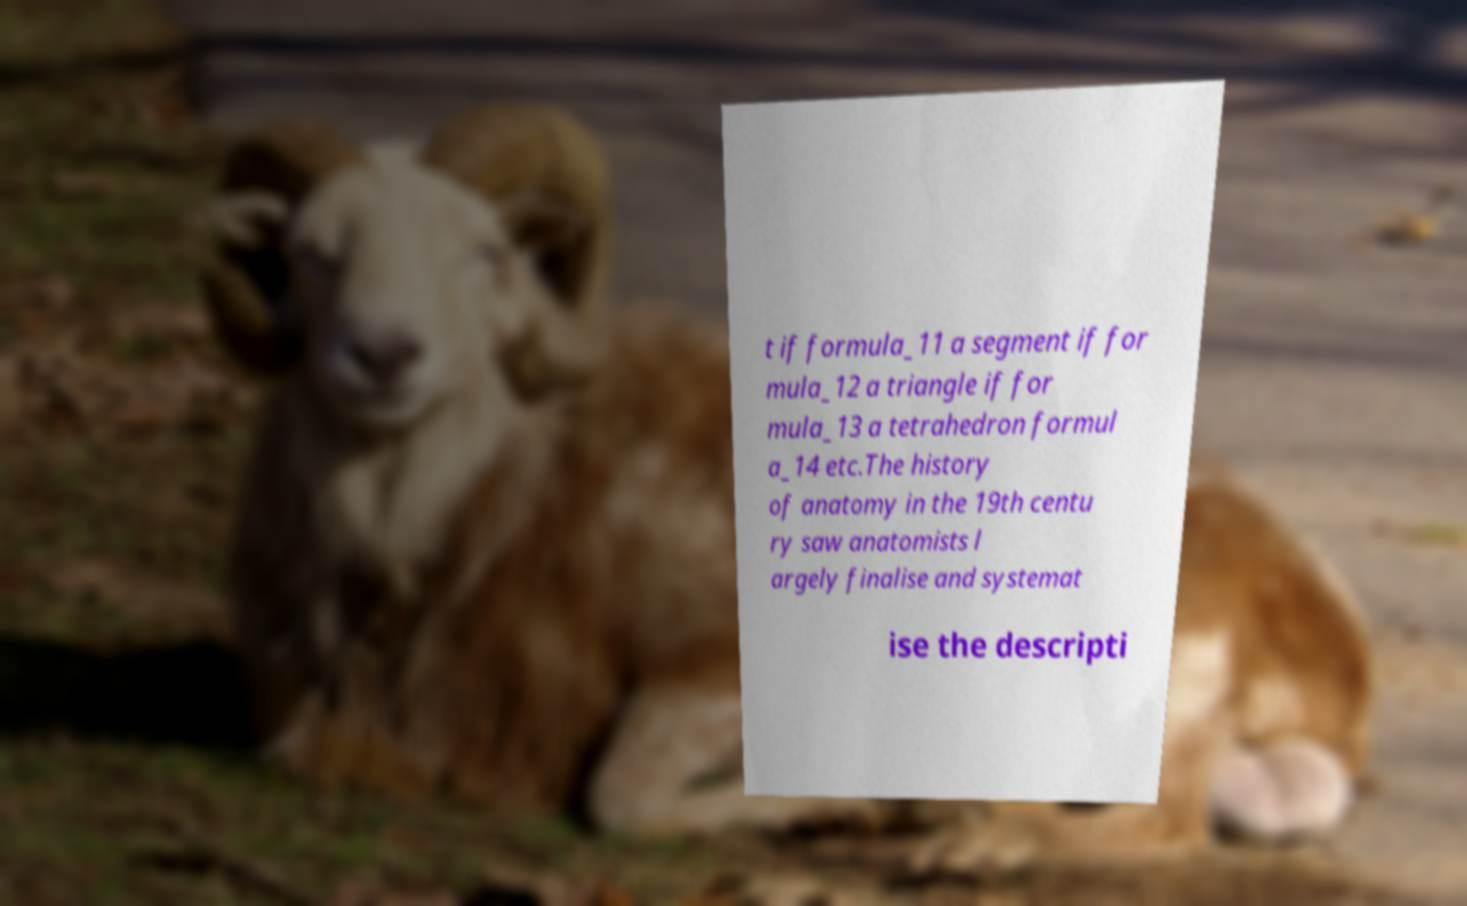Can you read and provide the text displayed in the image?This photo seems to have some interesting text. Can you extract and type it out for me? t if formula_11 a segment if for mula_12 a triangle if for mula_13 a tetrahedron formul a_14 etc.The history of anatomy in the 19th centu ry saw anatomists l argely finalise and systemat ise the descripti 